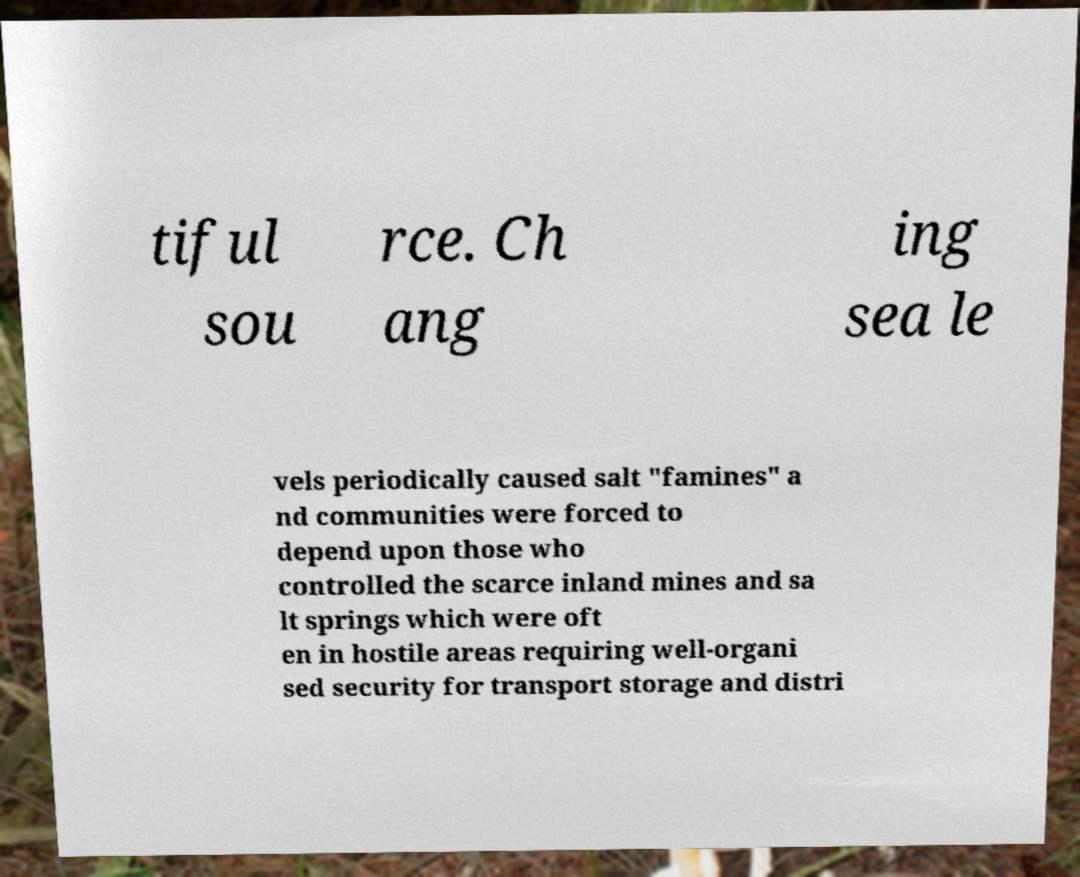For documentation purposes, I need the text within this image transcribed. Could you provide that? tiful sou rce. Ch ang ing sea le vels periodically caused salt "famines" a nd communities were forced to depend upon those who controlled the scarce inland mines and sa lt springs which were oft en in hostile areas requiring well-organi sed security for transport storage and distri 